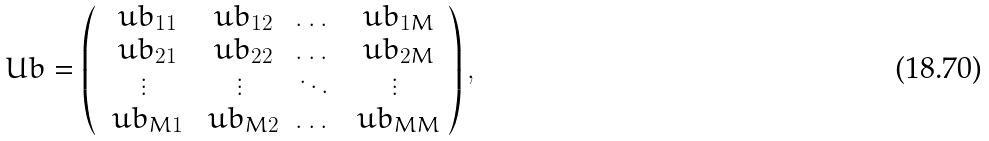<formula> <loc_0><loc_0><loc_500><loc_500>\ U b = \left ( \begin{array} { c c c c } \ u b _ { 1 1 } & \ u b _ { 1 2 } & \dots & \ u b _ { 1 M } \\ \ u b _ { 2 1 } & \ u b _ { 2 2 } & \dots & \ u b _ { 2 M } \\ \vdots & \vdots & \ddots & \vdots \\ \ u b _ { M 1 } & \ u b _ { M 2 } & \dots & \ u b _ { M M } \end{array} \right ) ,</formula> 